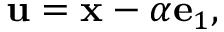<formula> <loc_0><loc_0><loc_500><loc_500>u = x - \alpha e _ { 1 } ,</formula> 